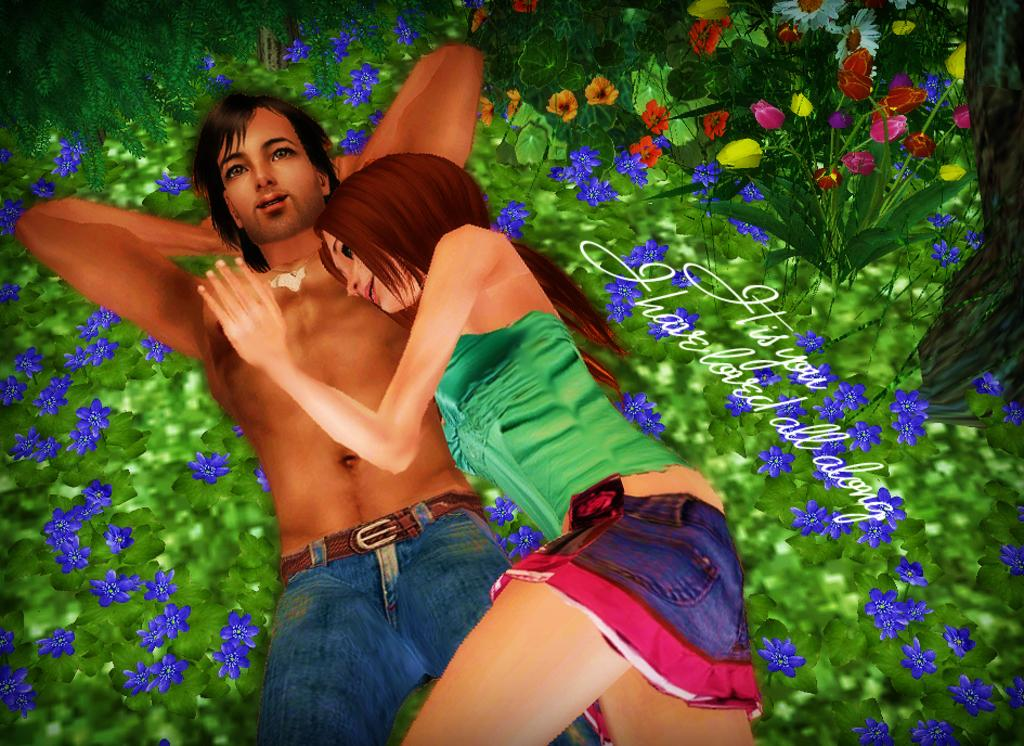What type of image is being described? The image is animated. What are the two people in the image doing? There is a man and a woman lying on the ground in the image. What kind of vegetation is present in the image? There are plants with flowers in the image. Is there any text present in the image? Yes, there is text present in the image. How many chances does the man have to fix the broken clock in the image? There is no clock present in the image, so the concept of chances to fix it does not apply. What type of paste is being used by the woman in the image? There is no paste or any activity involving paste in the image. 